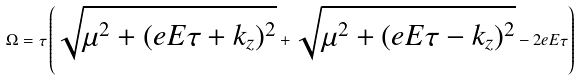<formula> <loc_0><loc_0><loc_500><loc_500>\Omega = \tau \left ( \sqrt { \mu ^ { 2 } + ( e E \tau + k _ { z } ) ^ { 2 } } + \sqrt { \mu ^ { 2 } + ( e E \tau - k _ { z } ) ^ { 2 } } - 2 e E \tau \right )</formula> 